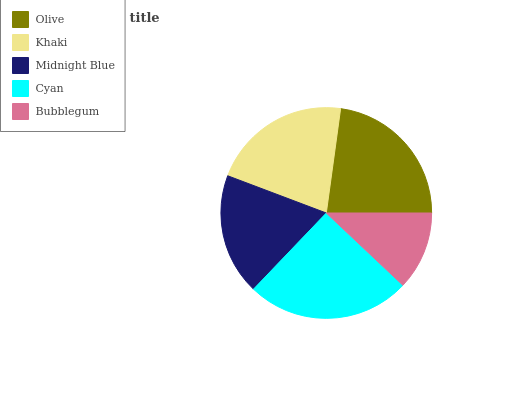Is Bubblegum the minimum?
Answer yes or no. Yes. Is Cyan the maximum?
Answer yes or no. Yes. Is Khaki the minimum?
Answer yes or no. No. Is Khaki the maximum?
Answer yes or no. No. Is Olive greater than Khaki?
Answer yes or no. Yes. Is Khaki less than Olive?
Answer yes or no. Yes. Is Khaki greater than Olive?
Answer yes or no. No. Is Olive less than Khaki?
Answer yes or no. No. Is Khaki the high median?
Answer yes or no. Yes. Is Khaki the low median?
Answer yes or no. Yes. Is Olive the high median?
Answer yes or no. No. Is Bubblegum the low median?
Answer yes or no. No. 